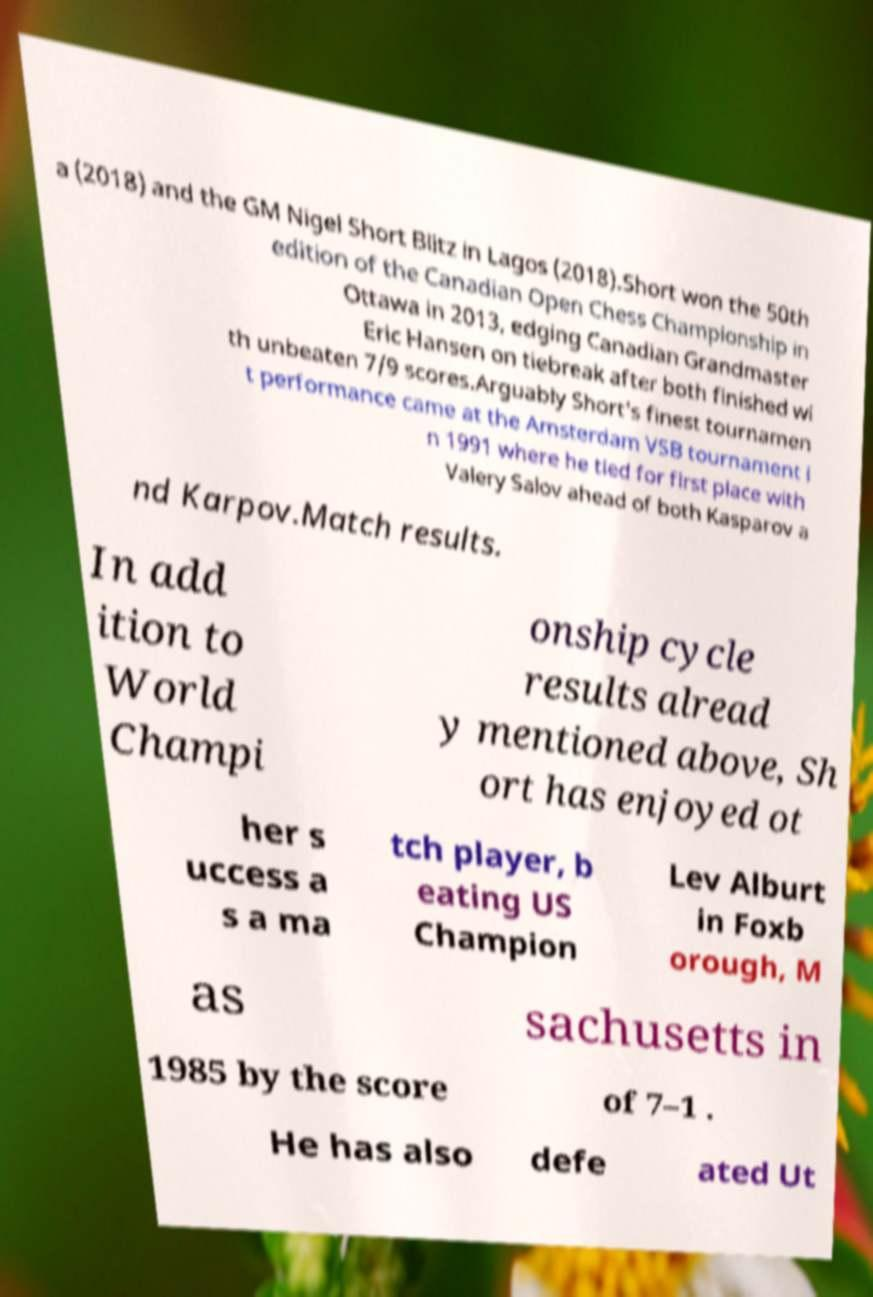Please read and relay the text visible in this image. What does it say? a (2018) and the GM Nigel Short Blitz in Lagos (2018).Short won the 50th edition of the Canadian Open Chess Championship in Ottawa in 2013, edging Canadian Grandmaster Eric Hansen on tiebreak after both finished wi th unbeaten 7/9 scores.Arguably Short's finest tournamen t performance came at the Amsterdam VSB tournament i n 1991 where he tied for first place with Valery Salov ahead of both Kasparov a nd Karpov.Match results. In add ition to World Champi onship cycle results alread y mentioned above, Sh ort has enjoyed ot her s uccess a s a ma tch player, b eating US Champion Lev Alburt in Foxb orough, M as sachusetts in 1985 by the score of 7–1 . He has also defe ated Ut 